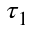<formula> <loc_0><loc_0><loc_500><loc_500>\tau _ { 1 }</formula> 